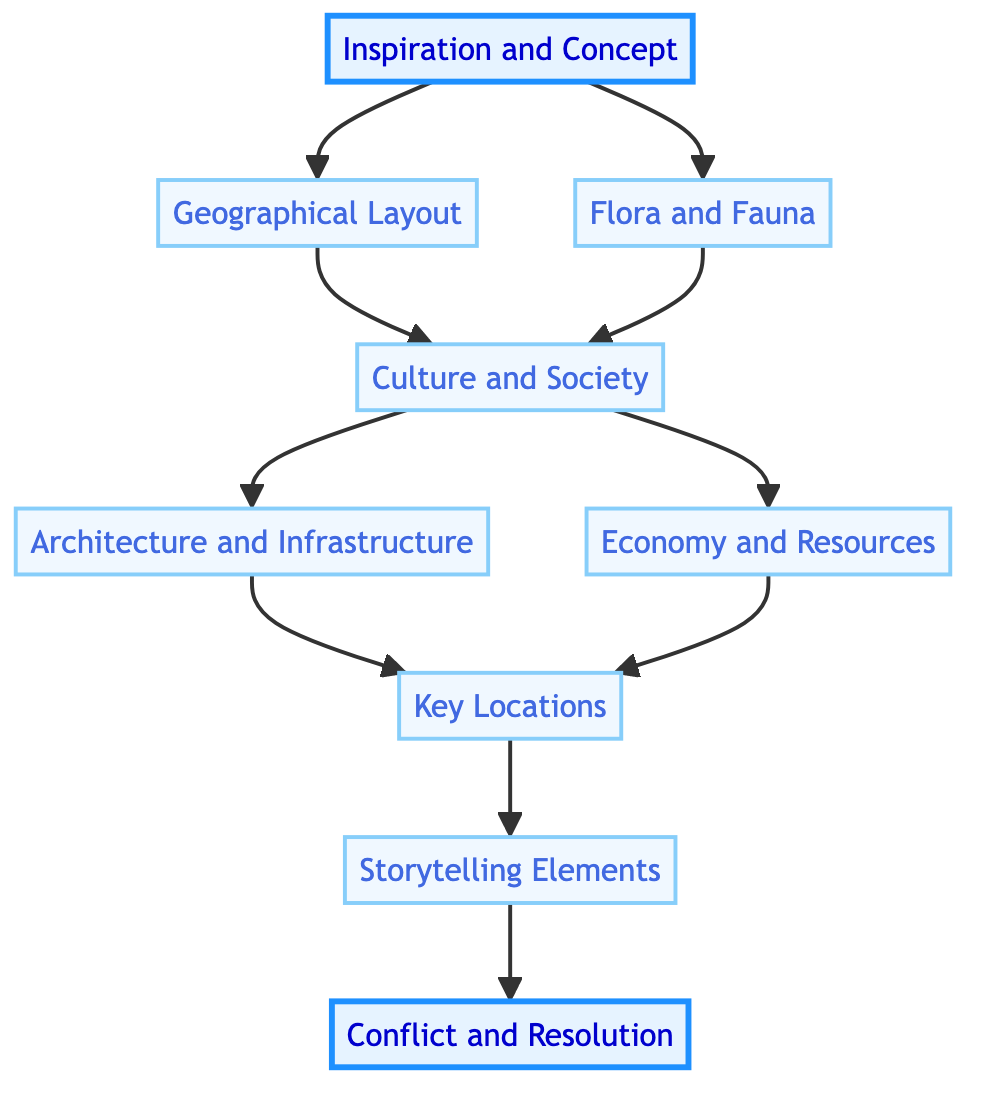What is the first step in the world-building journey? The first step is labeled "Inspiration and Concept," which serves as the foundational stage for constructing the universe.
Answer: Inspiration and Concept How many nodes are in the diagram? By counting each labeled component, there are a total of nine distinct nodes representing different aspects of the world-building journey.
Answer: 9 Which nodes lead directly to "Culture and Society"? The nodes "Geographical Layout" and "Flora and Fauna" both point directly to "Culture and Society," indicating they provide input or influence for it.
Answer: Geographical Layout, Flora and Fauna What node comes after "Key Locations"? The node that follows "Key Locations" in the flow chart is "Storytelling Elements," indicating the progression of ideas in the journey.
Answer: Storytelling Elements What is the final stage of the world-building journey? The last node or stage is "Conflict and Resolution," which concludes the flow of the journey by incorporating narratives that foster engagement.
Answer: Conflict and Resolution How many edges are in the diagram? Counting the lines that connect the nodes reveals there are ten edges indicating the relationships and flow between the various steps.
Answer: 10 Which node directly connects "Culture and Society" to the next step? The node that directly follows "Culture and Society" is "Architecture and Infrastructure," indicating an important link in the journey.
Answer: Architecture and Infrastructure What is the relationship between "Flora and Fauna" and "Economy and Resources"? "Flora and Fauna" has an indirect relationship with "Economy and Resources" as both nodes stem from "Culture and Society," influencing one another through societal interaction.
Answer: Indirect Relationship Which node highlights conflicts within the narrative? The node labeled "Conflict and Resolution" specifically addresses how conflicts are incorporated into the narrative, focusing on their resolution to maintain engagement.
Answer: Conflict and Resolution 